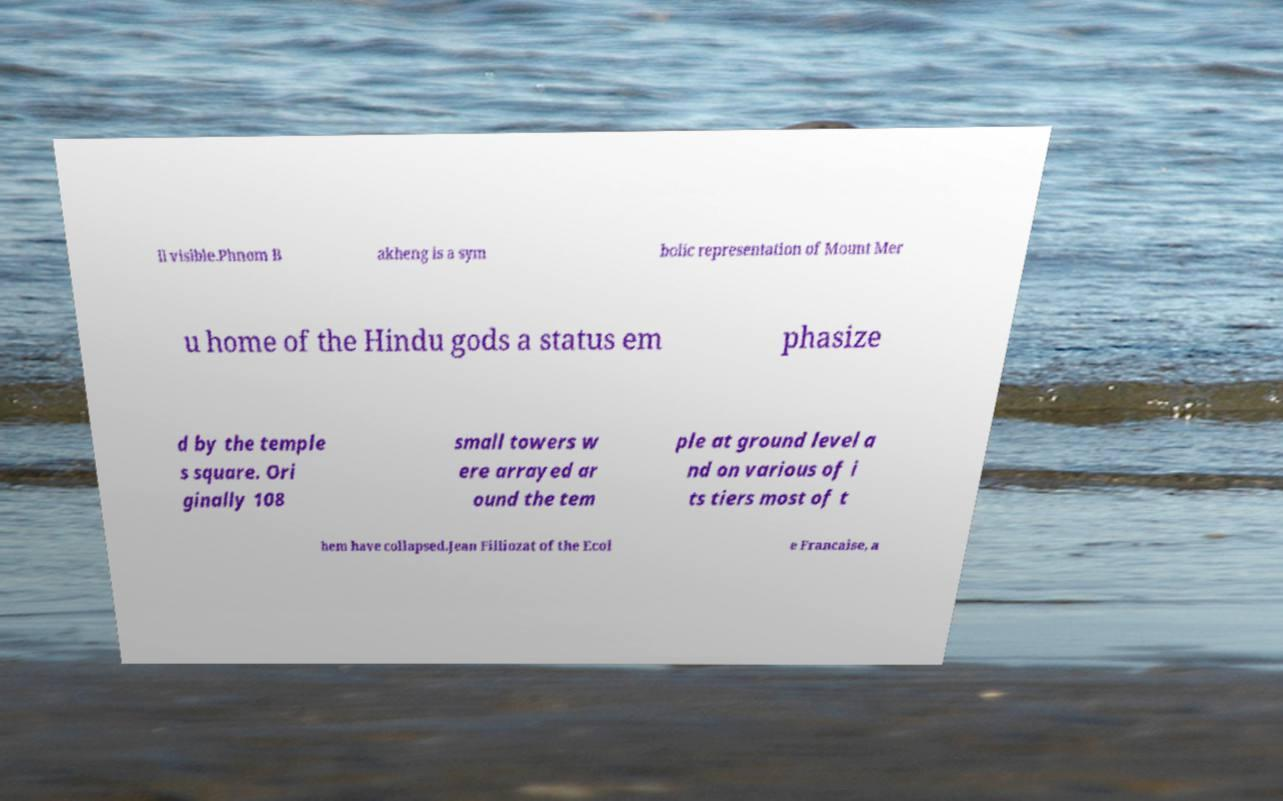Please read and relay the text visible in this image. What does it say? ll visible.Phnom B akheng is a sym bolic representation of Mount Mer u home of the Hindu gods a status em phasize d by the temple s square. Ori ginally 108 small towers w ere arrayed ar ound the tem ple at ground level a nd on various of i ts tiers most of t hem have collapsed.Jean Filliozat of the Ecol e Francaise, a 